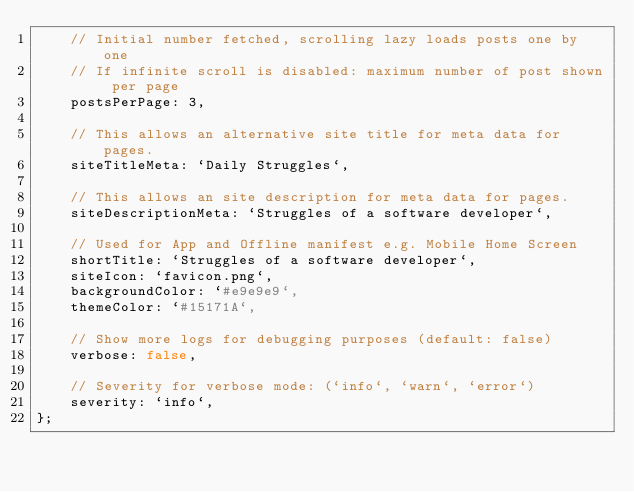<code> <loc_0><loc_0><loc_500><loc_500><_JavaScript_>    // Initial number fetched, scrolling lazy loads posts one by one
    // If infinite scroll is disabled: maximum number of post shown per page
    postsPerPage: 3,

    // This allows an alternative site title for meta data for pages.
    siteTitleMeta: `Daily Struggles`,

    // This allows an site description for meta data for pages.
    siteDescriptionMeta: `Struggles of a software developer`,

    // Used for App and Offline manifest e.g. Mobile Home Screen
    shortTitle: `Struggles of a software developer`,
    siteIcon: `favicon.png`,
    backgroundColor: `#e9e9e9`,
    themeColor: `#15171A`,

    // Show more logs for debugging purposes (default: false)
    verbose: false,

    // Severity for verbose mode: (`info`, `warn`, `error`)
    severity: `info`,
};
</code> 